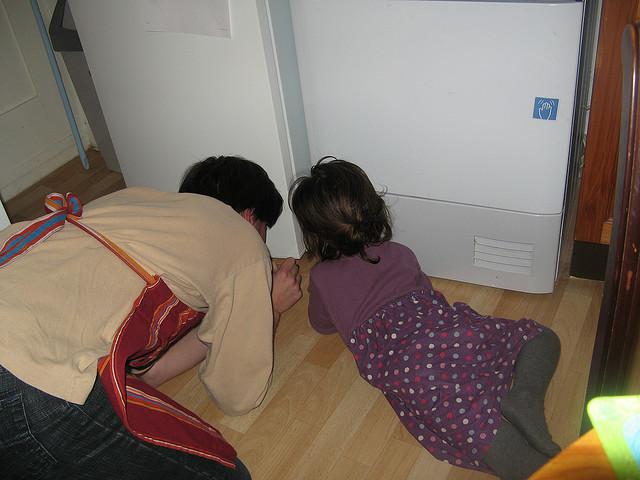Where is the girl sitting?
Keep it brief. Floor. What is lying beside child?
Answer briefly. Man. Is this child wearing a cap?
Give a very brief answer. No. What color is the backpack?
Keep it brief. No backpack. Is the floor brand new?
Concise answer only. Yes. Is there a mirror here?
Quick response, please. No. How many people are shown this picture?
Be succinct. 2. Is this girl in good health?
Short answer required. Yes. Is the girl wearing tights?
Write a very short answer. Yes. What are these people holding?
Give a very brief answer. Nothing. Are the people teammates?
Short answer required. No. What is above the woman's head?
Answer briefly. Wall. What is the pattern of the socks?
Give a very brief answer. Solid. What is she sitting on?
Quick response, please. Floor. How many people are in the photo?
Quick response, please. 2. What are the children doing?
Concise answer only. Laying down. What game are they playing?
Concise answer only. Unknown. What is the man lying on?
Keep it brief. Floor. Are these people facing the camera?
Answer briefly. No. What is on the wall in front of the men?
Be succinct. Paper. What color is the wall?
Keep it brief. White. Does the girl have tights on?
Concise answer only. Yes. How many cats are there?
Keep it brief. 0. What kind of flooring are the people on?
Concise answer only. Wood. What color is the girl's shirt?
Answer briefly. Purple. How many people are in the room?
Quick response, please. 2. What room is this in?
Write a very short answer. Kitchen. Do you see any phones?
Give a very brief answer. No. What color is the girl's hair?
Write a very short answer. Brown. 